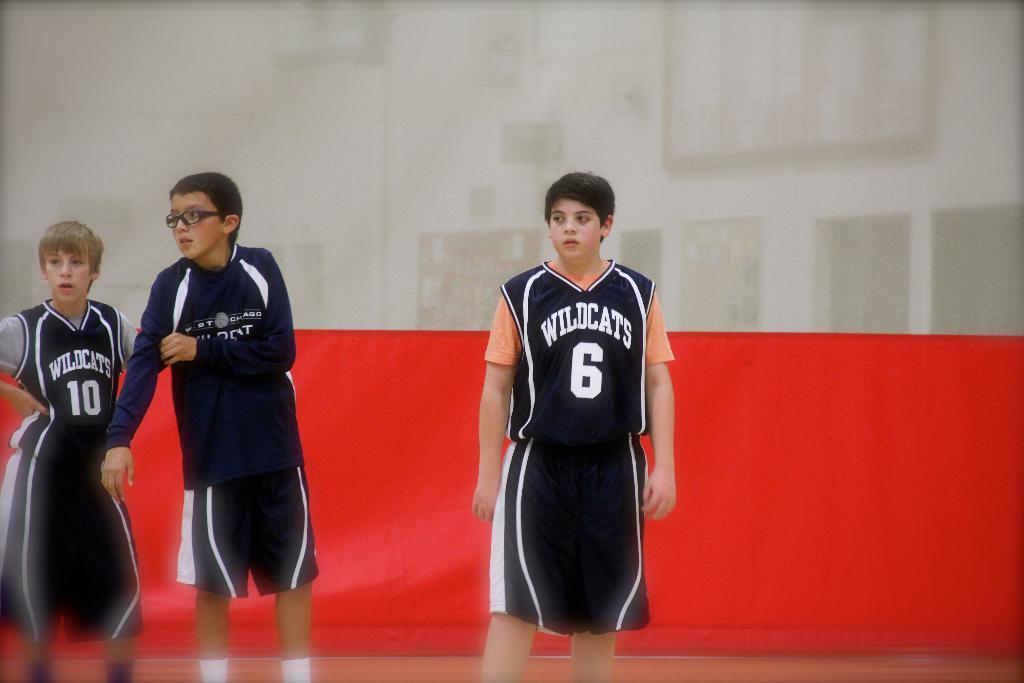What team is player 6 wearing?
Offer a very short reply. Wildcats. What is the number of the far left player?
Your answer should be very brief. 10. 